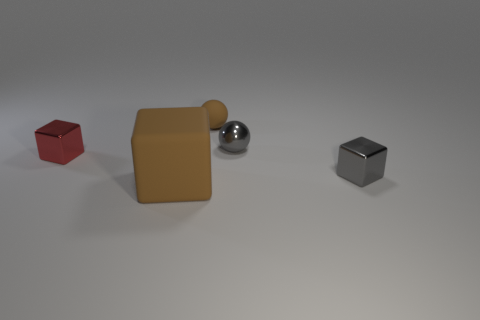How many other things are there of the same material as the big brown cube?
Your response must be concise. 1. There is a gray thing that is made of the same material as the small gray cube; what is its shape?
Keep it short and to the point. Sphere. Is there any other thing that has the same color as the tiny matte sphere?
Ensure brevity in your answer.  Yes. There is a rubber block that is the same color as the small matte sphere; what is its size?
Offer a terse response. Large. Are there more spheres in front of the brown ball than gray cylinders?
Make the answer very short. Yes. Does the small brown object have the same shape as the brown object in front of the brown ball?
Your answer should be compact. No. How many gray metallic cylinders are the same size as the metallic ball?
Your answer should be compact. 0. How many brown rubber things are behind the block to the left of the rubber thing in front of the red object?
Your answer should be very brief. 1. Are there an equal number of small brown rubber balls on the left side of the small red thing and small gray spheres left of the large matte cube?
Provide a short and direct response. Yes. How many other small objects are the same shape as the small brown rubber object?
Provide a short and direct response. 1. 